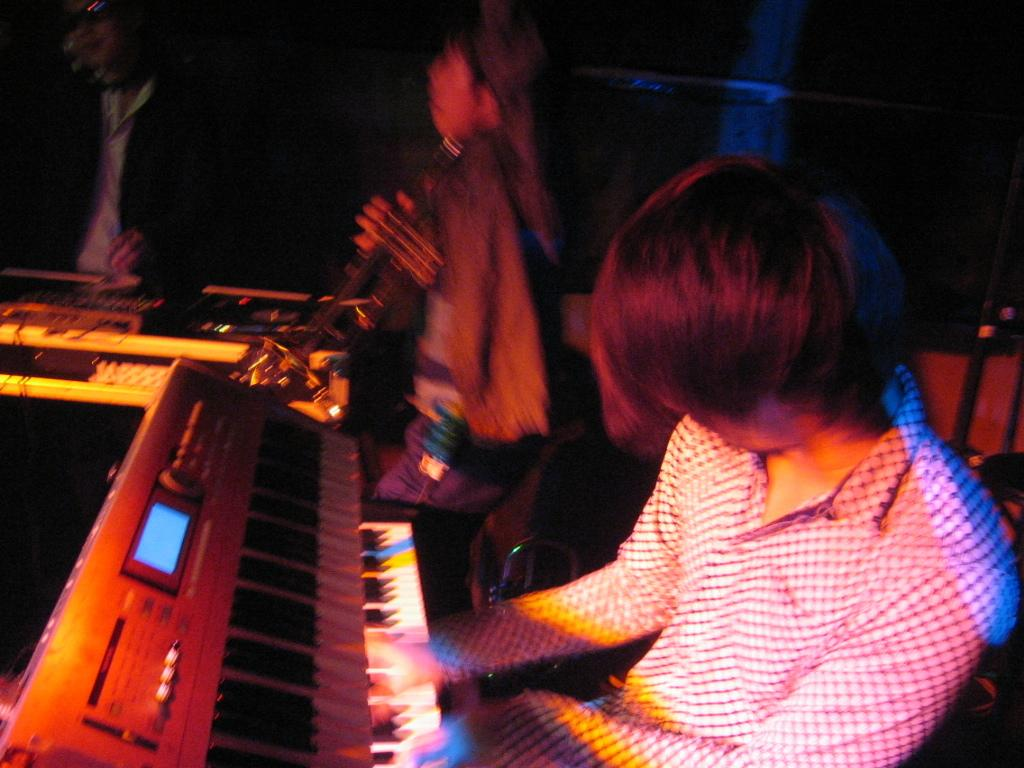How many people are in the image? There are three persons in the image. What are two of the persons doing in the image? Two of the persons are playing musical instruments. What is the third person doing in the image? The third person is standing at an amplifier. What type of bomb is the third person trying to defuse in the image? There is no bomb present in the image; the third person is standing at an amplifier. Who is the manager of the band in the image? The provided facts do not mention a band or a manager, so it cannot be determined from the image. 